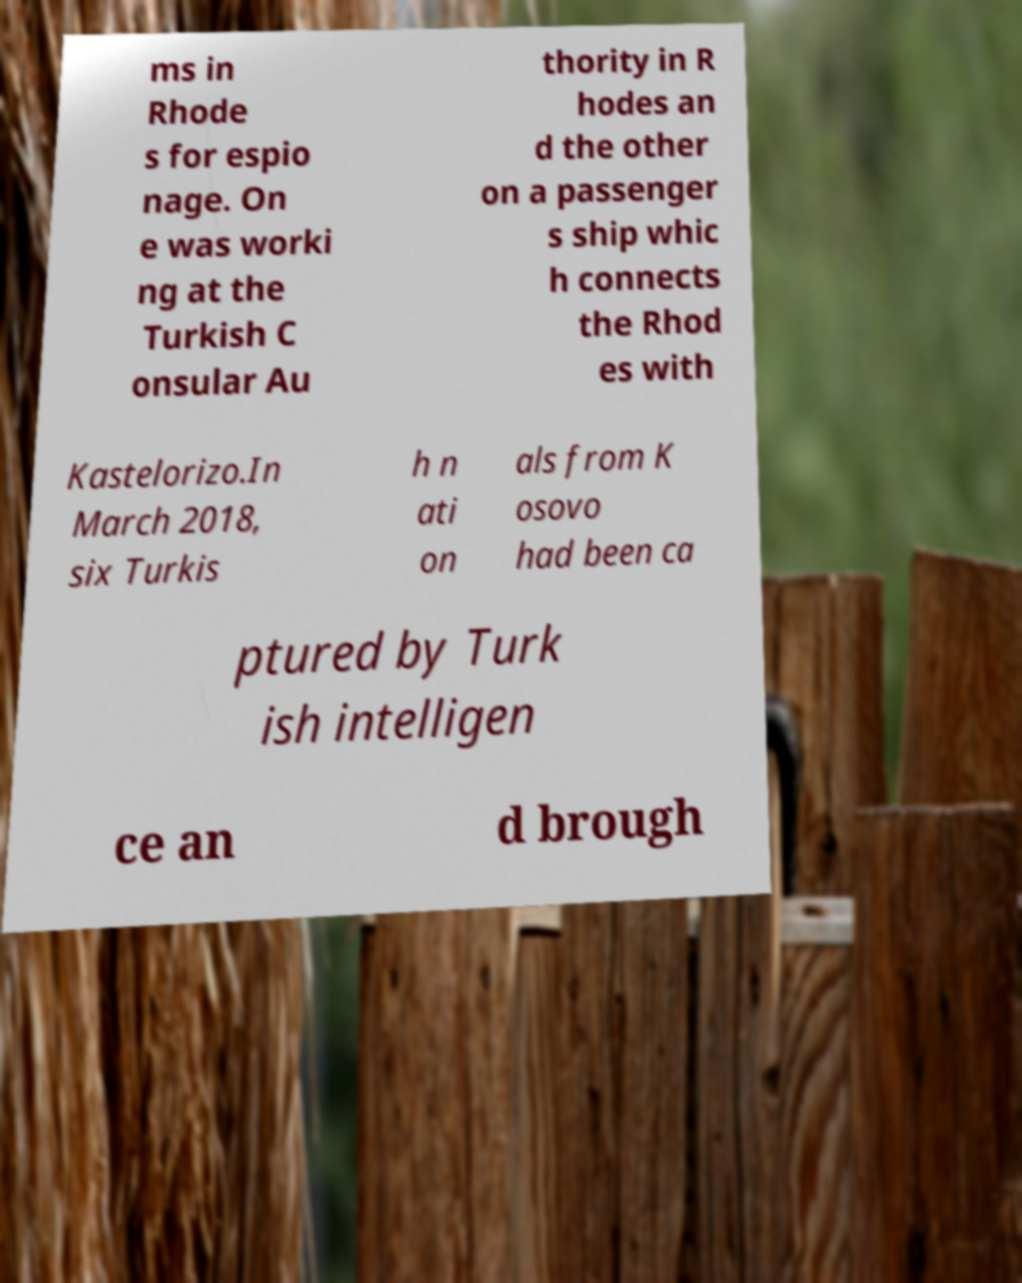What messages or text are displayed in this image? I need them in a readable, typed format. ms in Rhode s for espio nage. On e was worki ng at the Turkish C onsular Au thority in R hodes an d the other on a passenger s ship whic h connects the Rhod es with Kastelorizo.In March 2018, six Turkis h n ati on als from K osovo had been ca ptured by Turk ish intelligen ce an d brough 